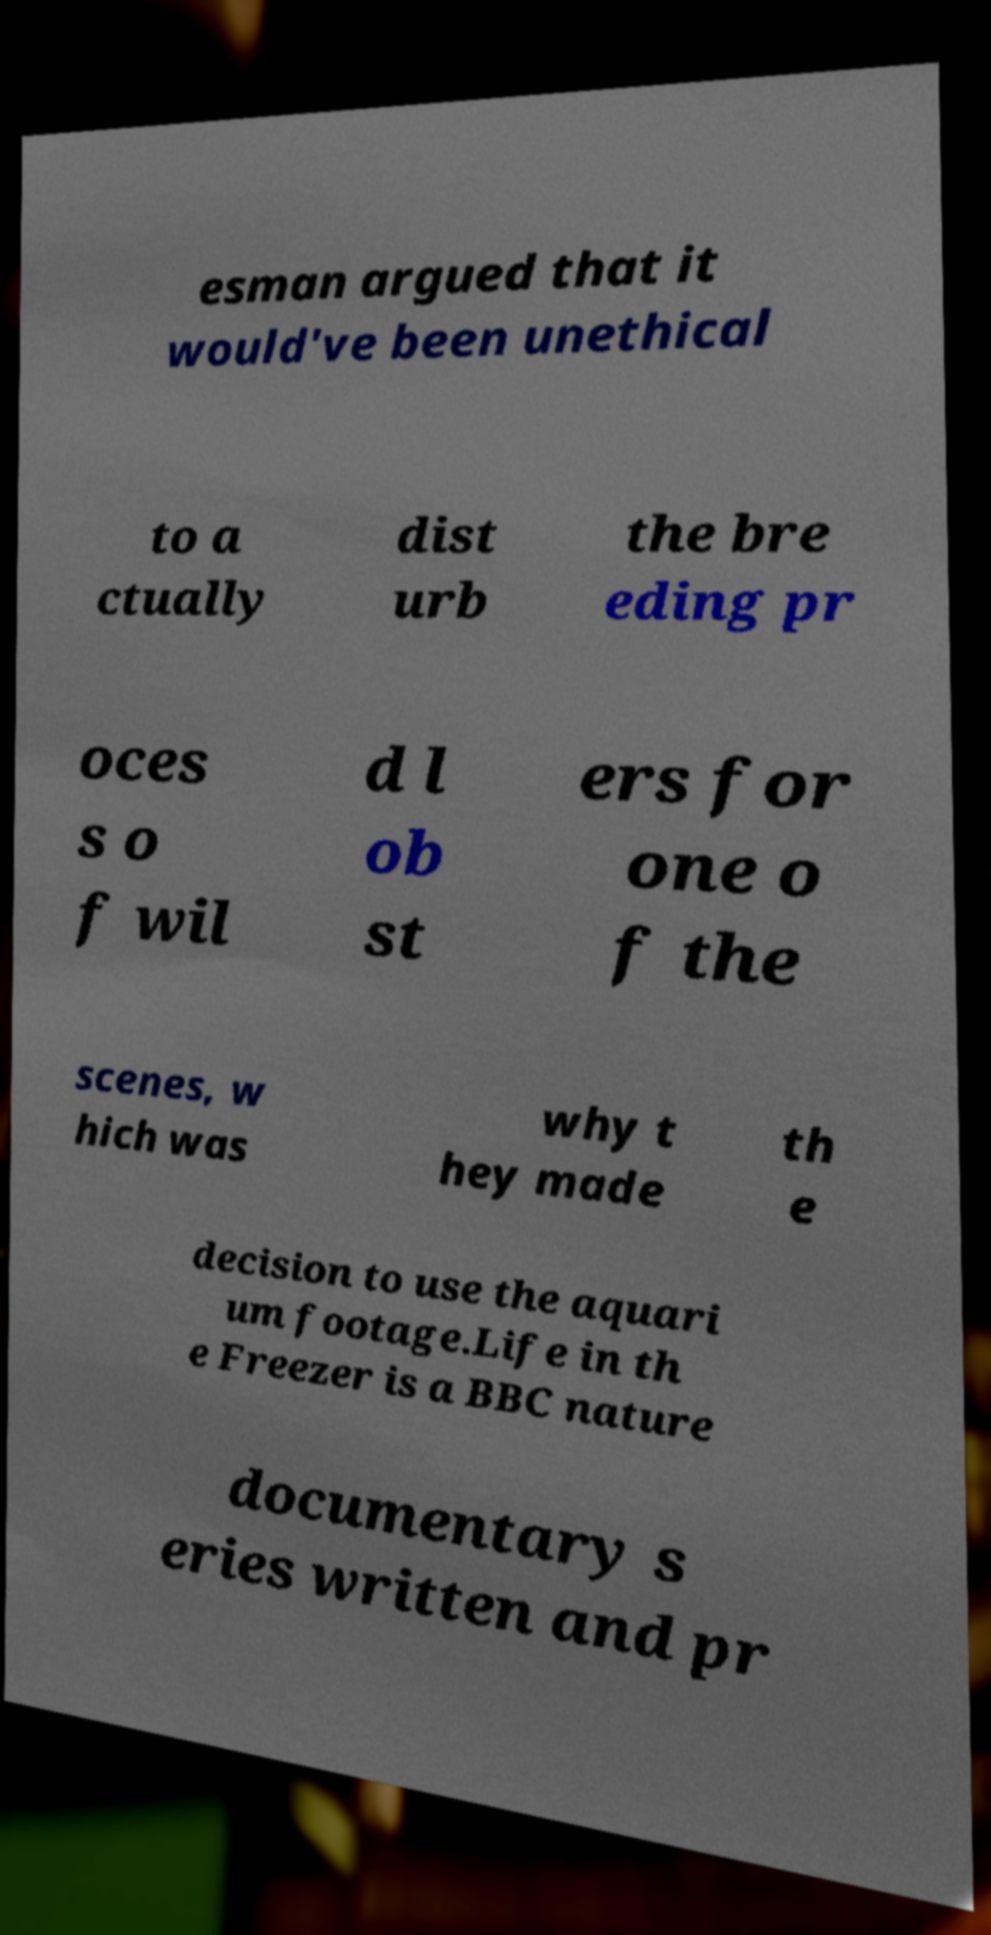Can you accurately transcribe the text from the provided image for me? esman argued that it would've been unethical to a ctually dist urb the bre eding pr oces s o f wil d l ob st ers for one o f the scenes, w hich was why t hey made th e decision to use the aquari um footage.Life in th e Freezer is a BBC nature documentary s eries written and pr 